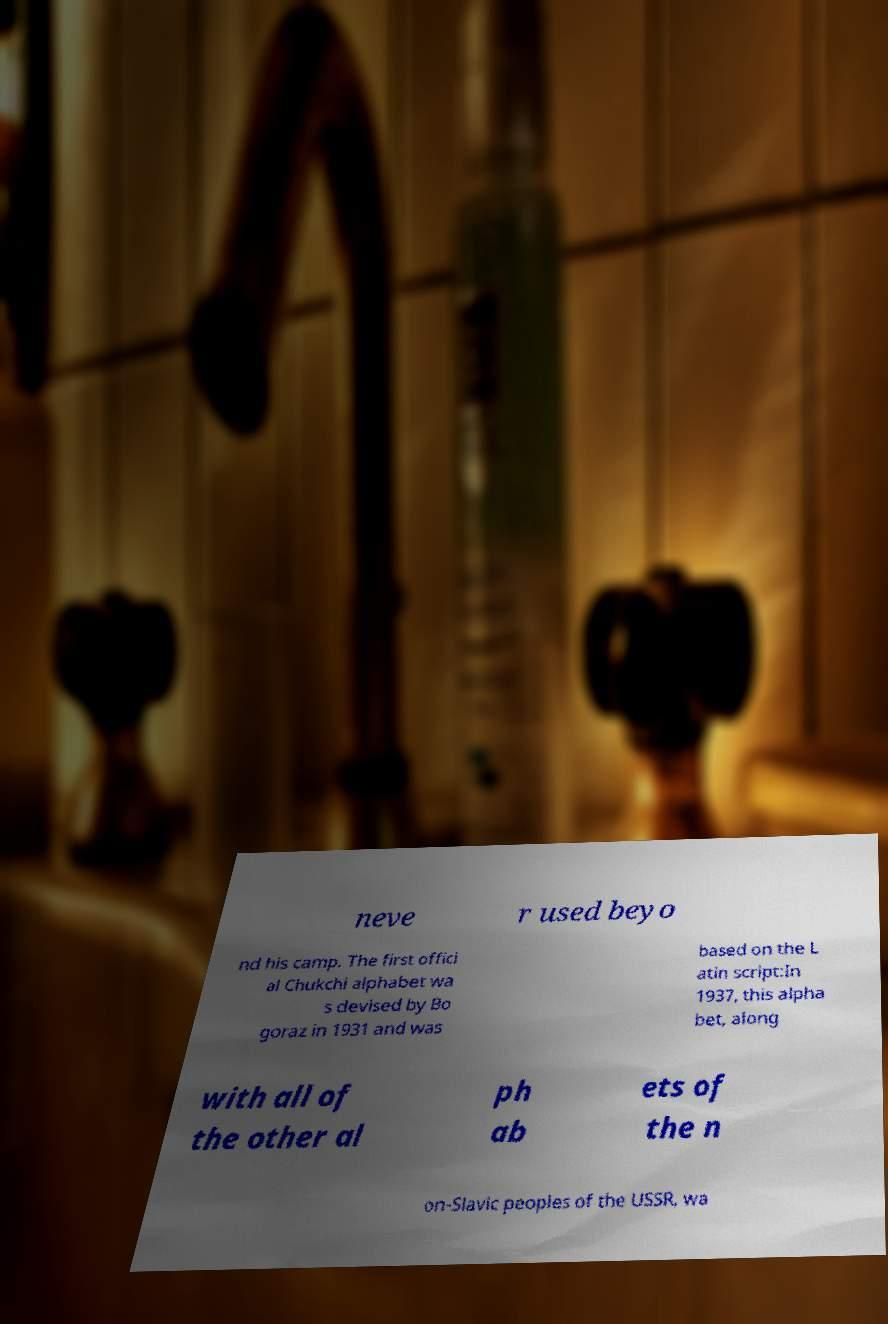Could you extract and type out the text from this image? neve r used beyo nd his camp. The first offici al Chukchi alphabet wa s devised by Bo goraz in 1931 and was based on the L atin script:In 1937, this alpha bet, along with all of the other al ph ab ets of the n on-Slavic peoples of the USSR, wa 